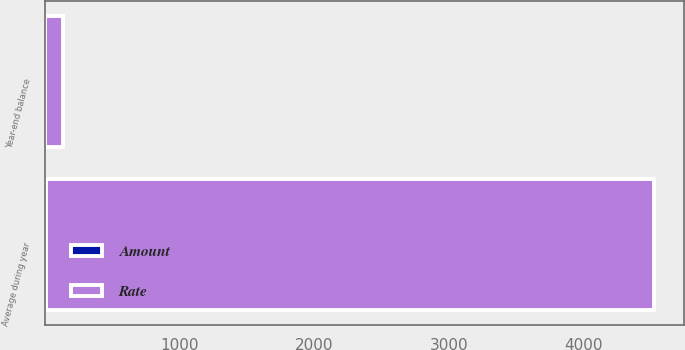<chart> <loc_0><loc_0><loc_500><loc_500><stacked_bar_chart><ecel><fcel>Year-end balance<fcel>Average during year<nl><fcel>Rate<fcel>128<fcel>4518<nl><fcel>Amount<fcel>0.01<fcel>2.15<nl></chart> 